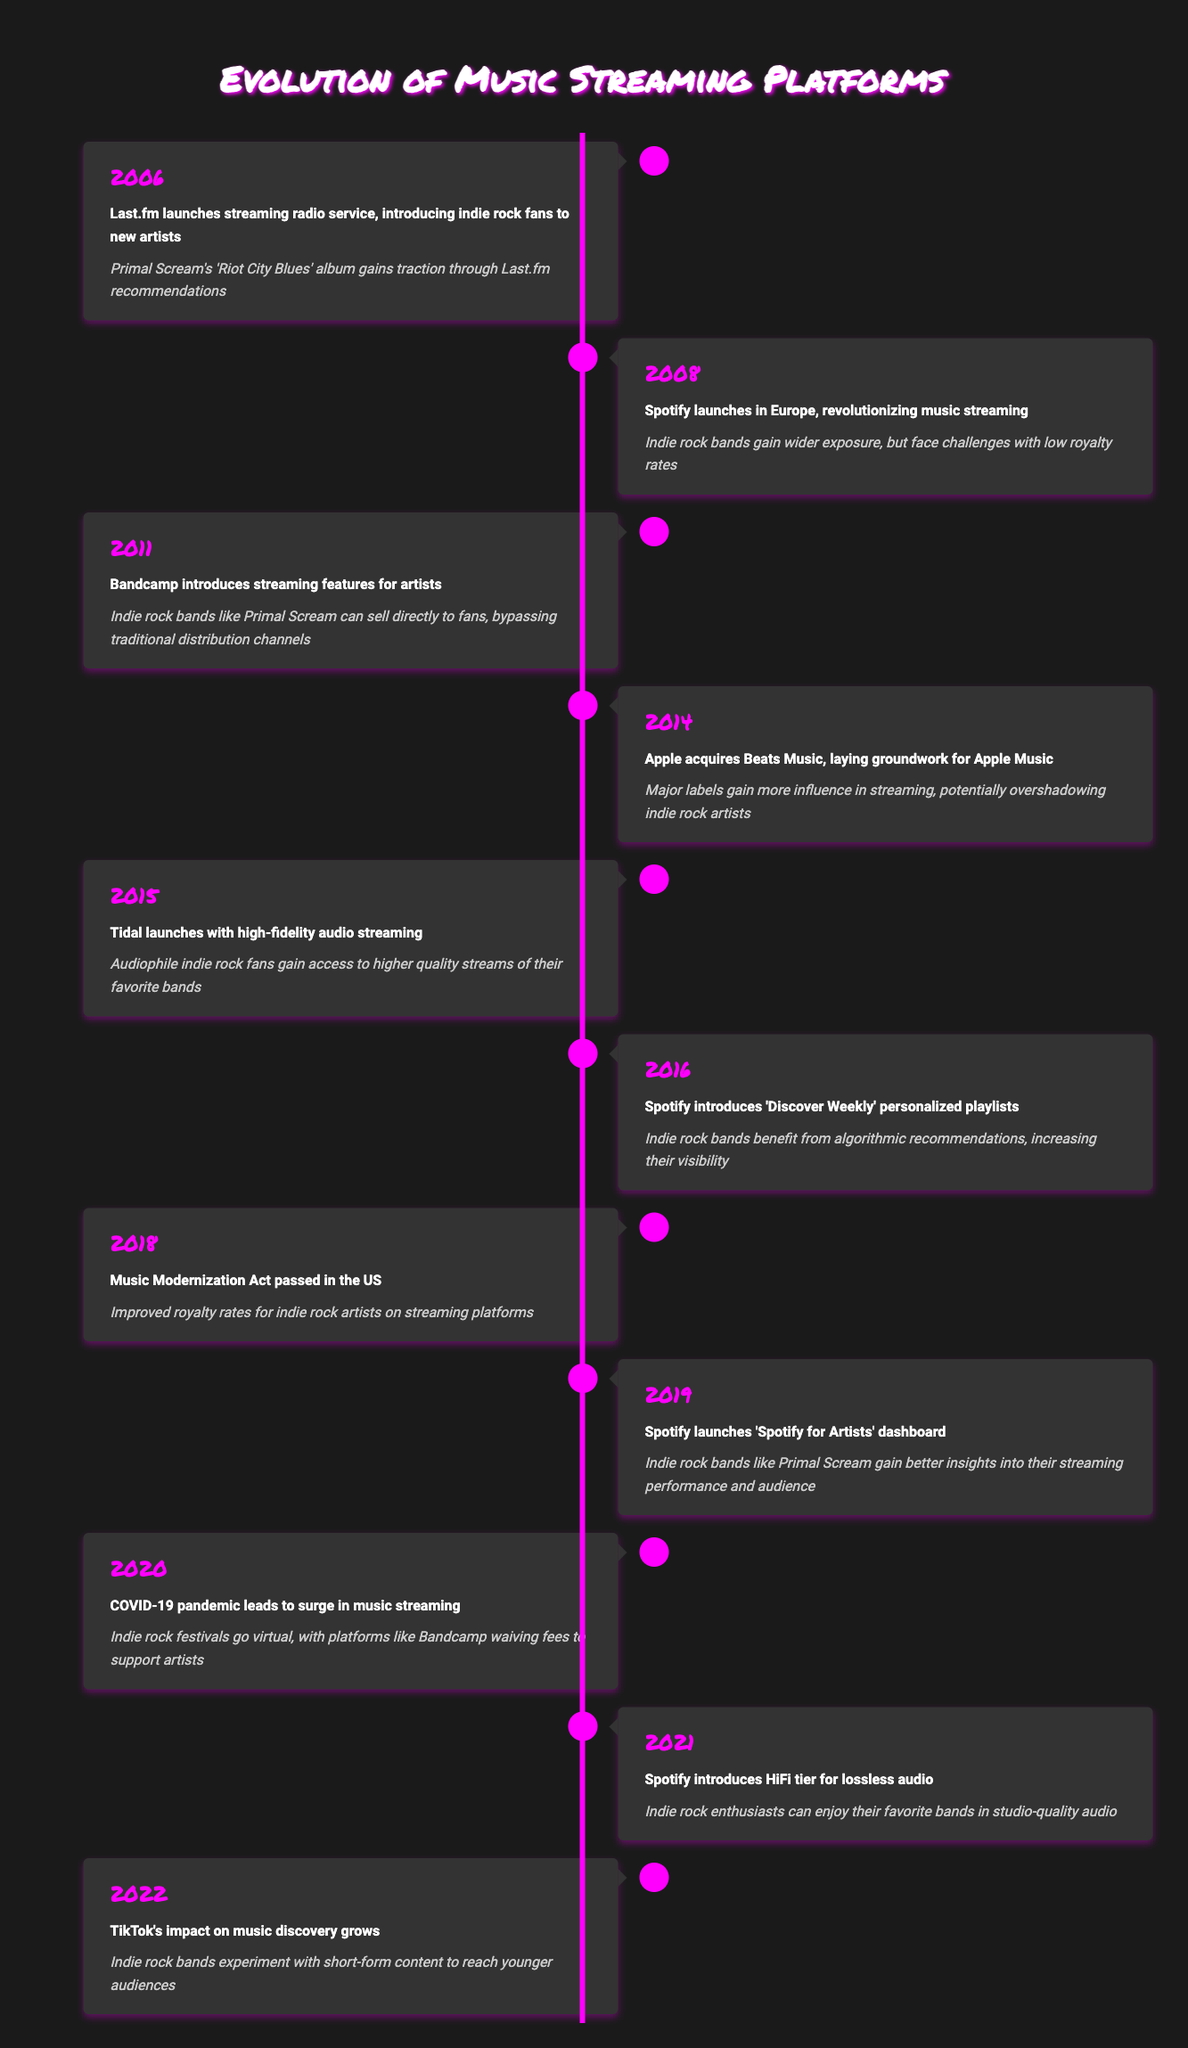What year did Last.fm launch its streaming radio service? According to the table, Last.fm launched its streaming radio service in 2006.
Answer: 2006 Which streaming platform introduced a HiFi tier for lossless audio in 2021? The table states that Spotify introduced the HiFi tier for lossless audio in 2021.
Answer: Spotify In what year did the Music Modernization Act pass? The table indicates that the Music Modernization Act passed in the year 2018.
Answer: 2018 Did Bandcamp introduce streaming features for artists before or after Spotify launched in Europe? The table shows that Spotify launched in Europe in 2008 and Bandcamp introduced streaming features in 2011, so Bandcamp introduced streaming features after Spotify.
Answer: After How many years passed between the launch of Spotify and the introduction of Spotify for Artists? Spotify launched in 2008 and Spotify for Artists was launched in 2019. The difference is 2019 - 2008 = 11 years.
Answer: 11 years What is the impact of the Music Modernization Act according to the table? The table states that the impact of the Music Modernization Act was improved royalty rates for indie rock artists on streaming platforms.
Answer: Improved royalty rates Which platform made a significant impact on indie rock bands by allowing direct sales to fans in 2011? Bandcamp, as noted in the table, allowed indie rock bands to sell directly to fans in 2011, bypassing traditional distribution channels.
Answer: Bandcamp How did the COVID-19 pandemic affect indie rock festivals according to the timeline? The timeline indicates that due to the COVID-19 pandemic, indie rock festivals went virtual with platforms like Bandcamp waiving fees to support artists.
Answer: Went virtual What year did TikTok's impact on music discovery grow? According to the table, TikTok's impact on music discovery grew in 2022.
Answer: 2022 Did indie rock bands face challenges with low royalty rates after Spotify's launch in Europe? Yes, the table clearly states that indie rock bands gained wider exposure but faced challenges with low royalty rates after Spotify's launch in 2008.
Answer: Yes 